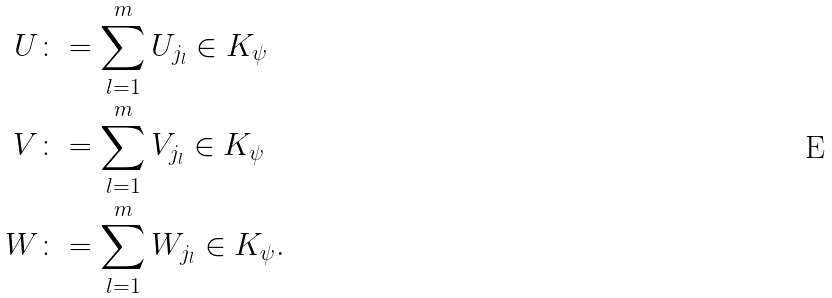<formula> <loc_0><loc_0><loc_500><loc_500>U & \colon = \sum _ { l = 1 } ^ { m } U _ { j _ { l } } \in K _ { \psi } \\ V & \colon = \sum _ { l = 1 } ^ { m } V _ { j _ { l } } \in K _ { \psi } \\ W & \colon = \sum _ { l = 1 } ^ { m } W _ { j _ { l } } \in K _ { \psi } . \\</formula> 